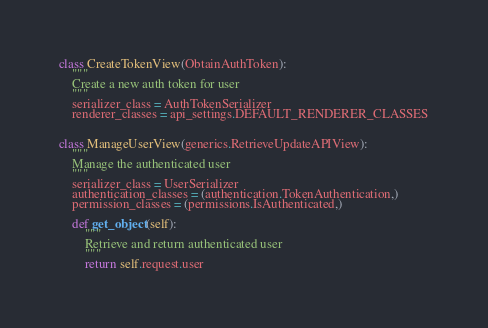Convert code to text. <code><loc_0><loc_0><loc_500><loc_500><_Python_>

class CreateTokenView(ObtainAuthToken):
    """
    Create a new auth token for user
    """
    serializer_class = AuthTokenSerializer
    renderer_classes = api_settings.DEFAULT_RENDERER_CLASSES


class ManageUserView(generics.RetrieveUpdateAPIView):
    """
    Manage the authenticated user
    """
    serializer_class = UserSerializer
    authentication_classes = (authentication.TokenAuthentication,)
    permission_classes = (permissions.IsAuthenticated,)

    def get_object(self):
        """
        Retrieve and return authenticated user
        """
        return self.request.user
</code> 